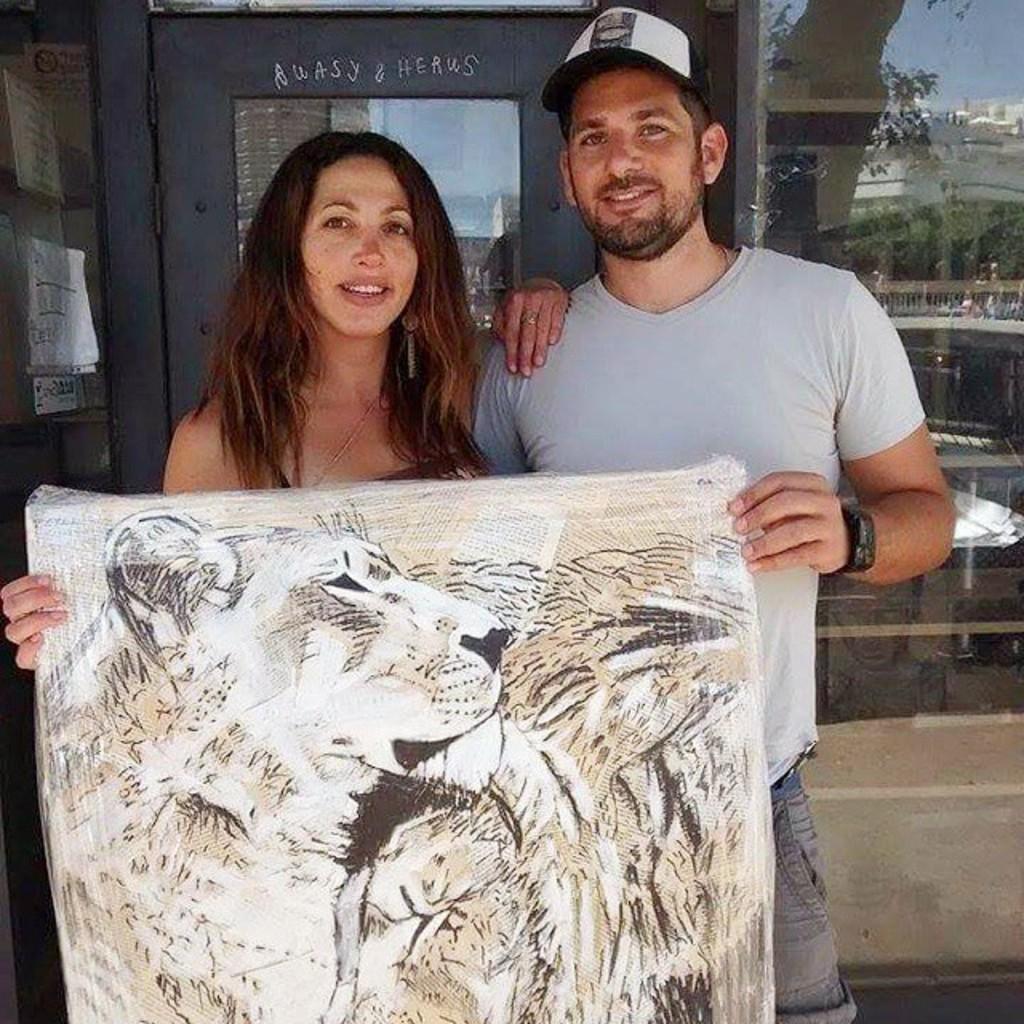Describe this image in one or two sentences. In this image there is a woman. Beside there is a person standing. They are holding a cloth having a painting on it. The person is wearing a cap. Behind them there is a glass wall having a door. On the glass wall there is a reflection of buildings and trees. Left side there are posters attached to the wall. 